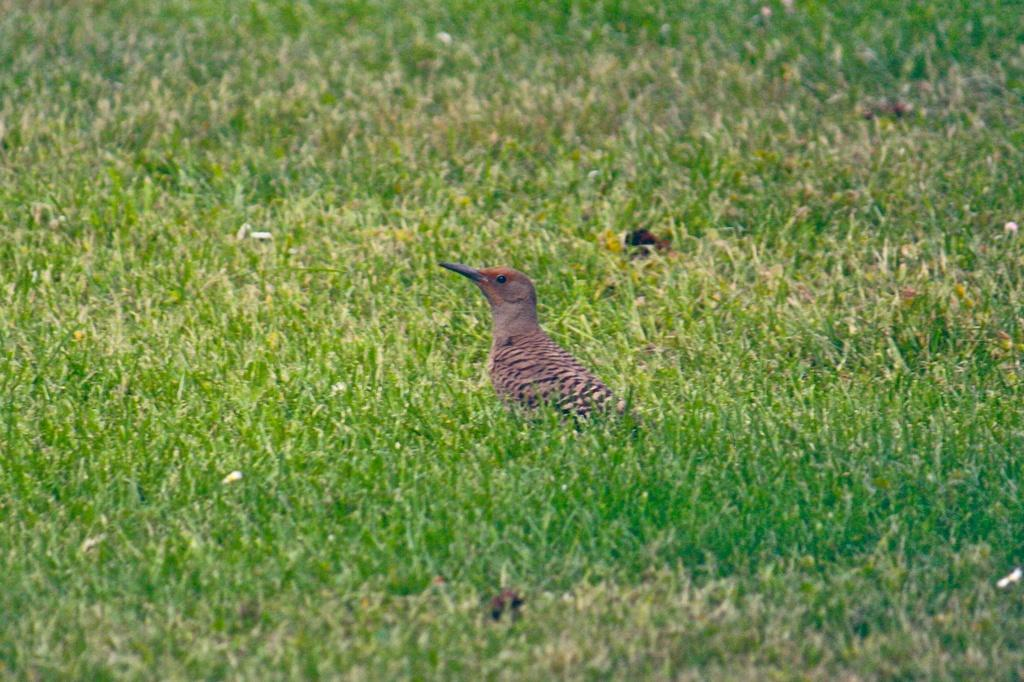What type of animal can be seen in the image? There is a bird in the image. Where is the bird located? The bird is on the grass. Is the bird in the image located in a building? No, the bird is not in a building; it is on the grass. Is the bird feeling hot in the image? The provided facts do not mention the bird's temperature, so we cannot determine if it is feeling hot. 